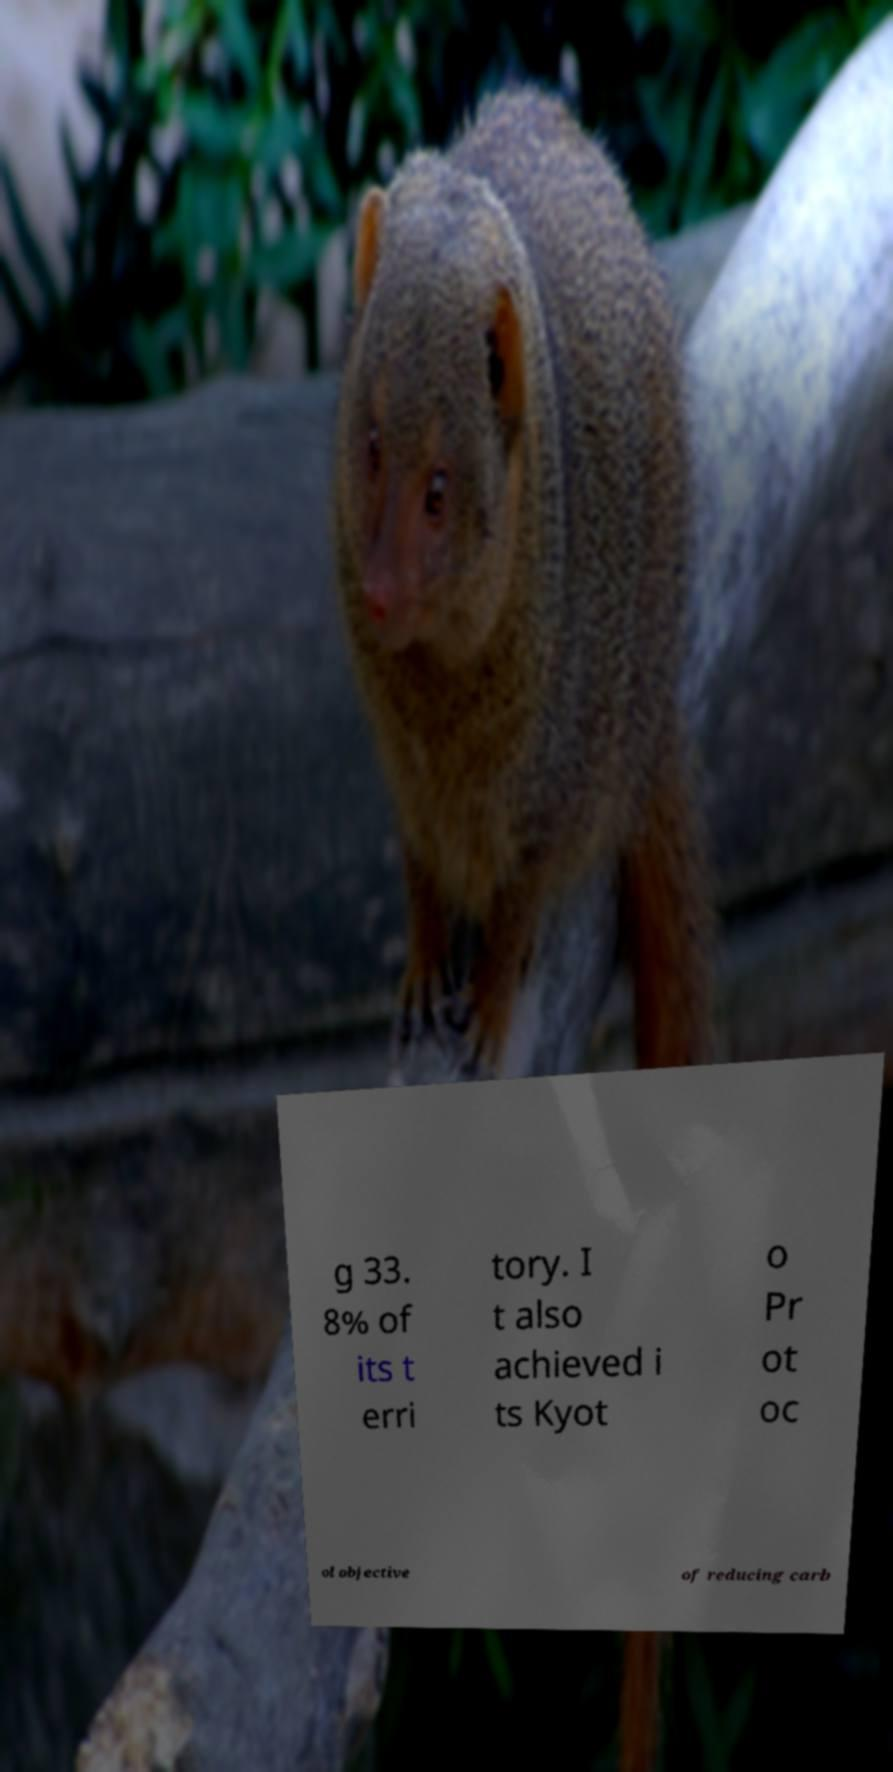There's text embedded in this image that I need extracted. Can you transcribe it verbatim? g 33. 8% of its t erri tory. I t also achieved i ts Kyot o Pr ot oc ol objective of reducing carb 